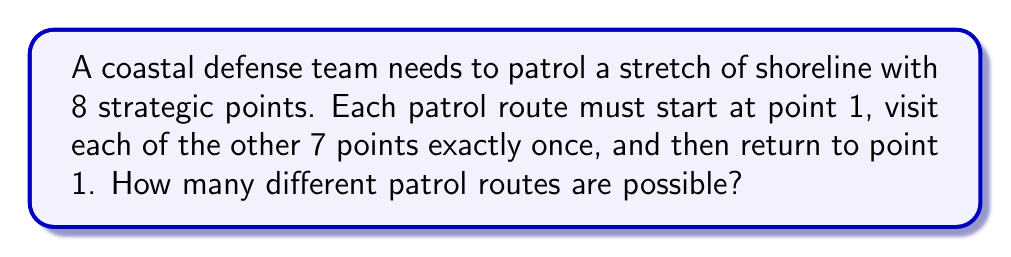Give your solution to this math problem. Let's approach this step-by-step:

1) This problem is a variation of the Travelling Salesman Problem, where we need to find the number of possible routes visiting each point once and returning to the start.

2) We start at point 1 and need to arrange the other 7 points in all possible orders.

3) The number of ways to arrange 7 points is 7! (7 factorial).

4) After visiting all 7 points, we always return to point 1, so this last step doesn't increase the number of possibilities.

5) Therefore, the total number of different patrol routes is:

   $$7! = 7 \times 6 \times 5 \times 4 \times 3 \times 2 \times 1 = 5040$$

6) We can also express this using the permutation notation:

   $$P(7,7) = 7! = 5040$$

Thus, there are 5040 different possible patrol routes.
Answer: 5040 